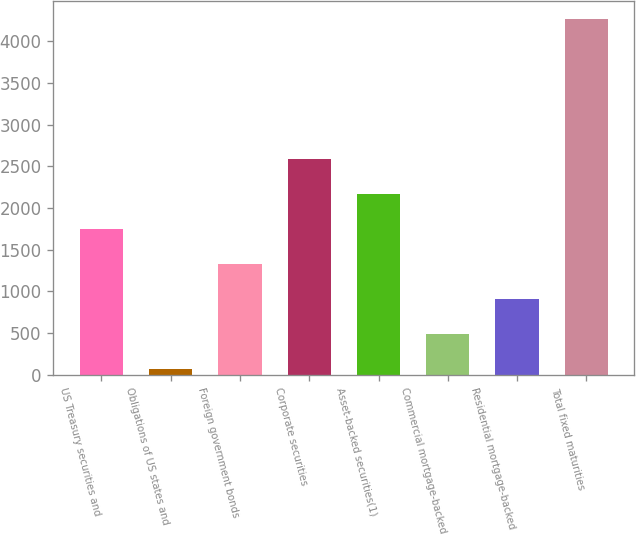<chart> <loc_0><loc_0><loc_500><loc_500><bar_chart><fcel>US Treasury securities and<fcel>Obligations of US states and<fcel>Foreign government bonds<fcel>Corporate securities<fcel>Asset-backed securities(1)<fcel>Commercial mortgage-backed<fcel>Residential mortgage-backed<fcel>Total fixed maturities<nl><fcel>1746.8<fcel>66<fcel>1326.6<fcel>2587.2<fcel>2167<fcel>486.2<fcel>906.4<fcel>4268<nl></chart> 